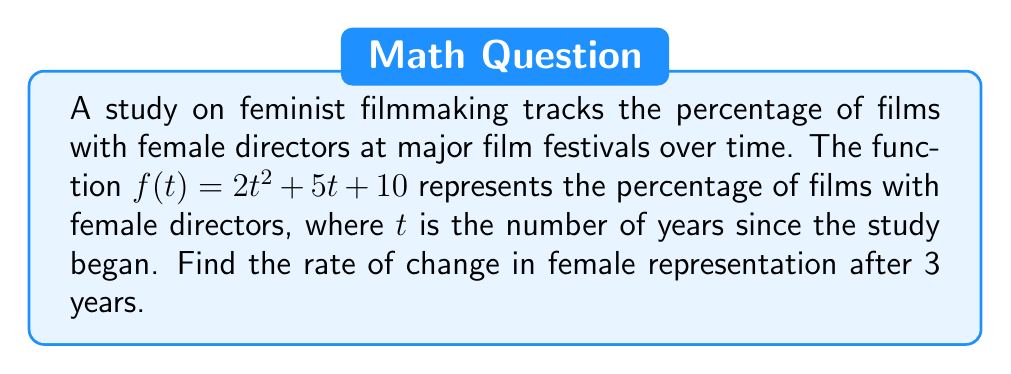Show me your answer to this math problem. To find the rate of change in female representation after 3 years, we need to calculate the derivative of the given function $f(t)$ and evaluate it at $t=3$. Here's how we do it:

1. Given function: $f(t) = 2t^2 + 5t + 10$

2. To find the derivative, we apply the power rule and constant rule:
   $$f'(t) = 4t + 5$$

3. Now, we evaluate $f'(t)$ at $t=3$:
   $$f'(3) = 4(3) + 5 = 12 + 5 = 17$$

This means that after 3 years, the rate of change in female representation is 17 percentage points per year.
Answer: 17 percentage points per year 